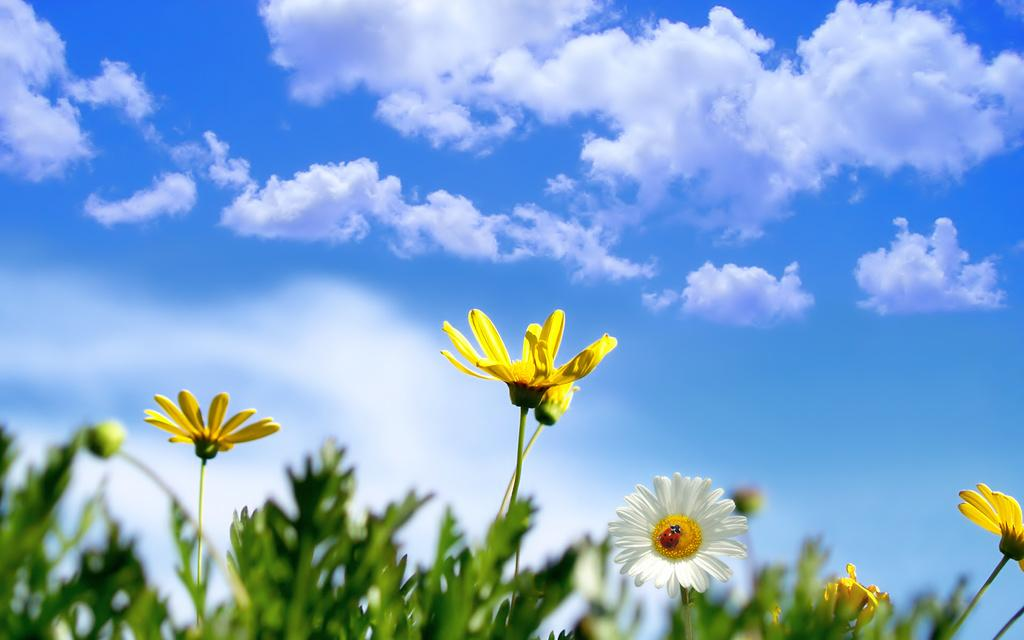What type of plants are present in the image? There are plants with flowers in the image. Where are the plants located in the image? The plants are at the bottom of the image. What can be seen in the background of the image? The sky is visible in the background of the image. What is the condition of the sky in the image? The sky is cloudy in the image. What is the daughter learning in the image? There is no daughter present in the image, and therefore no learning activity can be observed. 